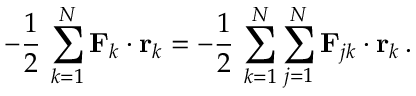<formula> <loc_0><loc_0><loc_500><loc_500>- { \frac { 1 } { 2 } } \, \sum _ { k = 1 } ^ { N } F _ { k } \cdot r _ { k } = - { \frac { 1 } { 2 } } \, \sum _ { k = 1 } ^ { N } \sum _ { j = 1 } ^ { N } F _ { j k } \cdot r _ { k } \, .</formula> 